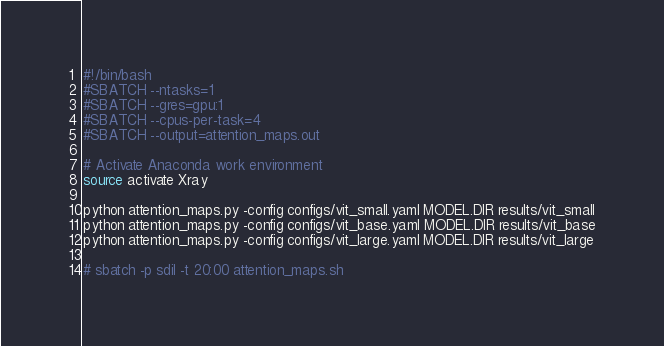Convert code to text. <code><loc_0><loc_0><loc_500><loc_500><_Bash_>#!/bin/bash
#SBATCH --ntasks=1
#SBATCH --gres=gpu:1
#SBATCH --cpus-per-task=4
#SBATCH --output=attention_maps.out

# Activate Anaconda work environment
source activate Xray

python attention_maps.py -config configs/vit_small.yaml MODEL.DIR results/vit_small
python attention_maps.py -config configs/vit_base.yaml MODEL.DIR results/vit_base
python attention_maps.py -config configs/vit_large.yaml MODEL.DIR results/vit_large

# sbatch -p sdil -t 20:00 attention_maps.sh</code> 